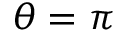Convert formula to latex. <formula><loc_0><loc_0><loc_500><loc_500>\theta = \pi</formula> 